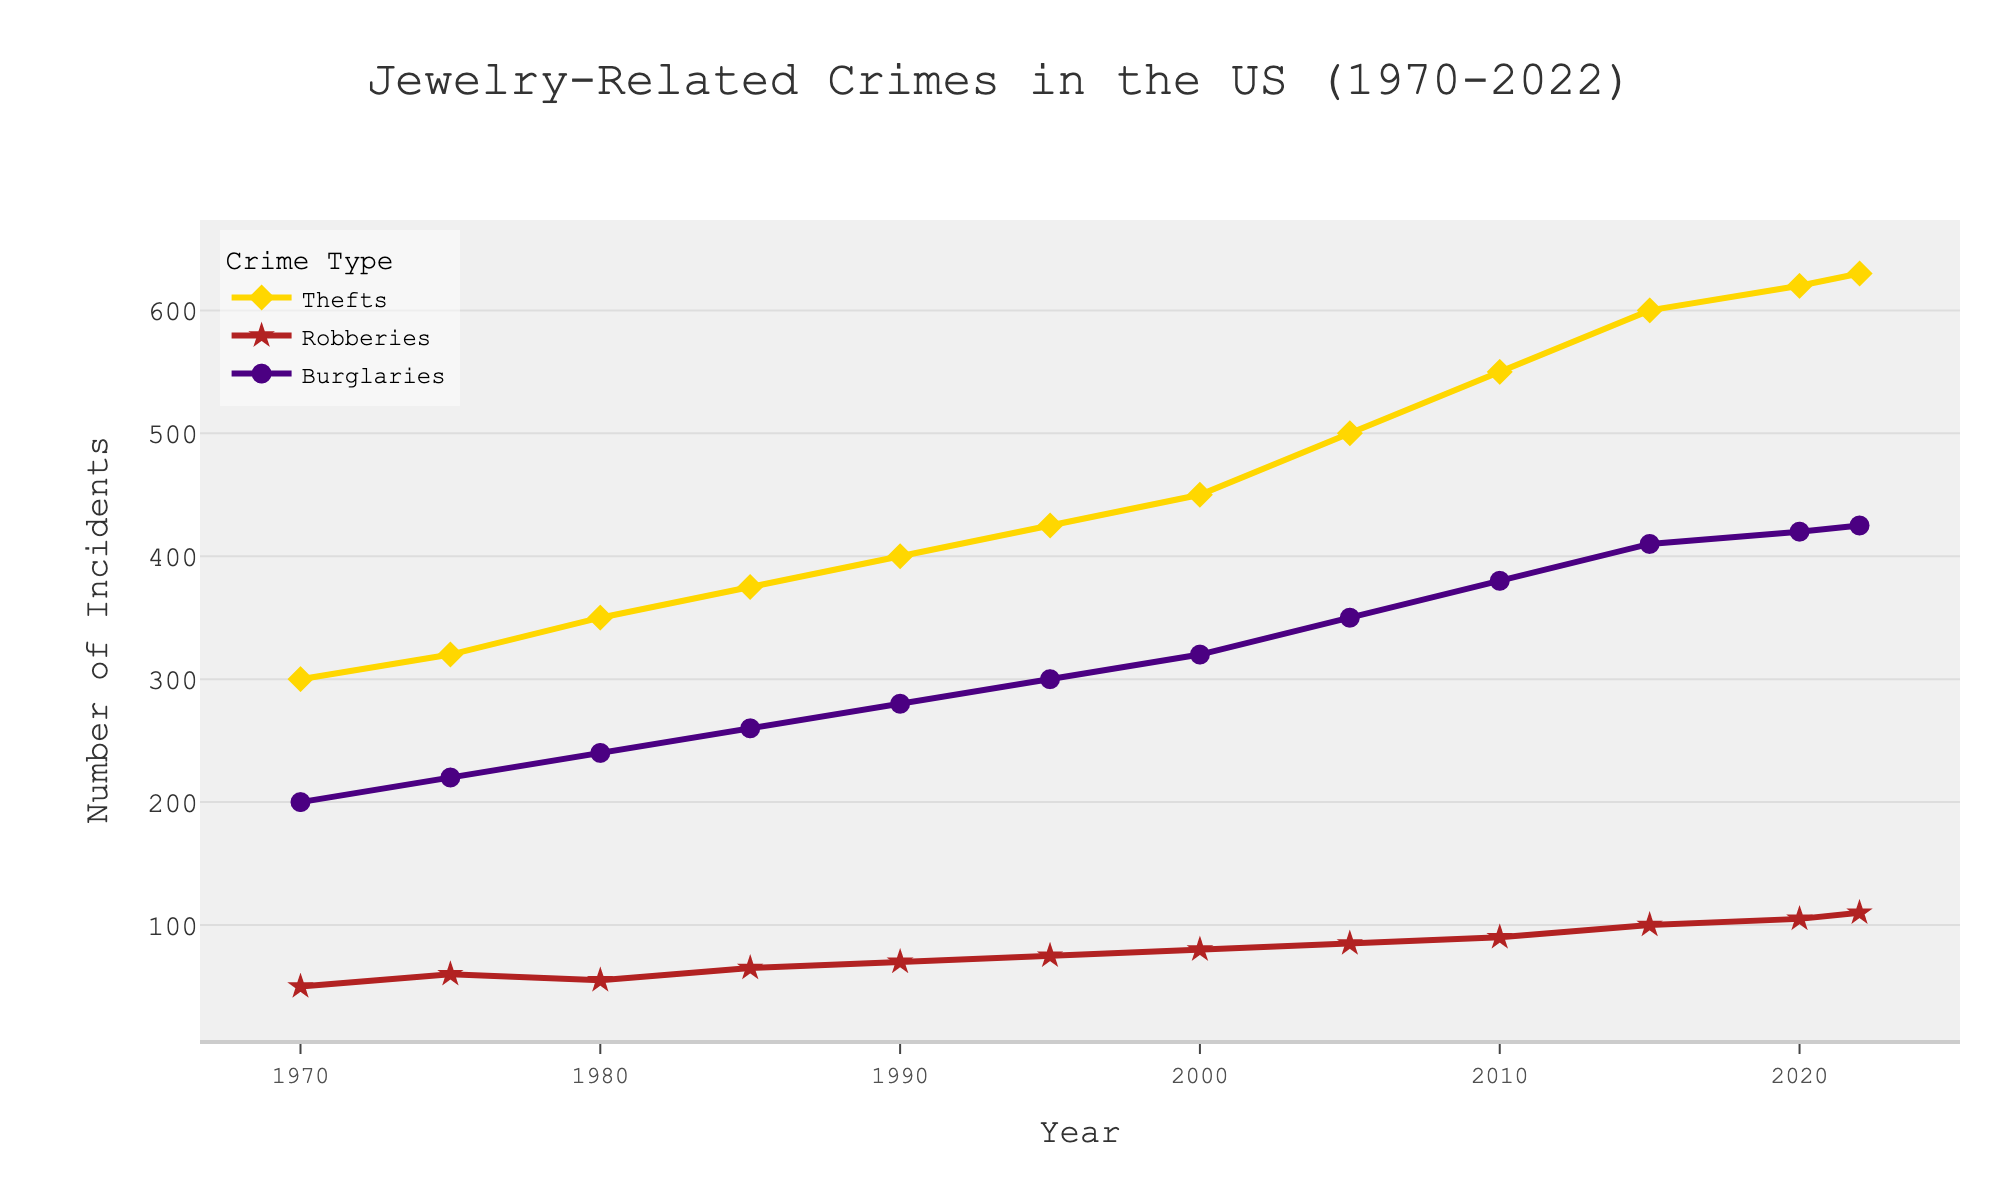what is the title of the plot? The title of the plot is usually displayed prominently at the top. In this case, it reads "Jewelry-Related Crimes in the US (1970-2022)"
Answer: Jewelry-Related Crimes in the US (1970-2022) What are the types of crimes tracked in the plot? The plot has a legend on the right-hand side indicating the different types of crimes tracked. The crimes tracked are Thefts, Robberies, and Burglaries
Answer: Thefts, Robberies, Burglaries Which type of crime had the highest number in 2022? To find this, look at the ending points of each line on the x-axis at 2022. The line representing Thefts is the highest at 630 incidents
Answer: Thefts What year did robberies surpass 70 incidents? By following the Robberies line, we see that it surpasses 70 incidents around the year 1990
Answer: 1990 How many total incidents (sum of all three types) occurred in 1980? Add the numbers for Thefts (350), Robberies (55), and Burglaries (240): 350 + 55 + 240 = 645
Answer: 645 Between which years did burglaries increase the most? By examining the Burglaries line, the most significant increase seems to occur between 2000 (320) and 2005 (350), showing an increase of 30 incidents
Answer: 2000 and 2005 What is the difference in the number of thefts between 1970 and 2022? The number of thefts in 1970 was 300, and in 2022 it was 630. The difference is 630 - 300 = 330 incidents
Answer: 330 What is the average number of robberies between 2000 and 2020 (inclusive)? Robberies in 2000: 80, 2005: 85, 2010: 90, 2015: 100, 2020: 105. The average is (80 + 85 + 90 + 100 + 105) / 5 = 92
Answer: 92 How did the number of burglaries change from 1980 to 2022? The number of burglaries in 1980 was 240, and in 2022 it was 425. The change is 425 - 240 = 185 incidents
Answer: Increased by 185 Which type of crime shows the most gradual increase over the years? By comparing the slopes of the lines, Robberies has the most gradual increase over the years
Answer: Robberies 